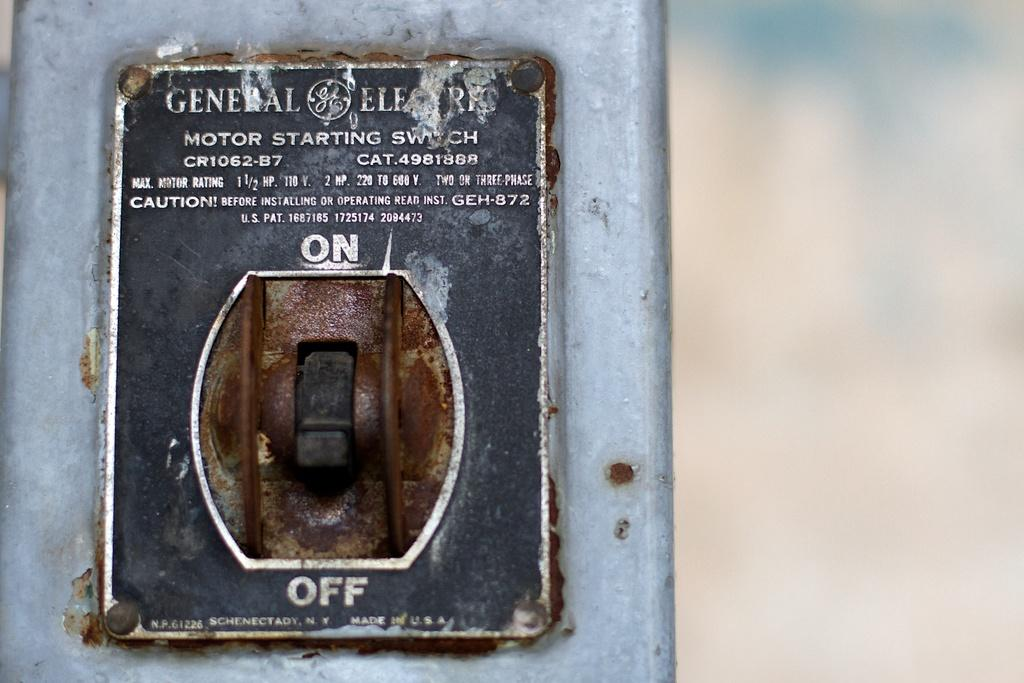What type of object is located on the left side of the image? There is a metal object on the left side of the image. What can be found on the metal object? The metal object has text on it and a switch. What is visible on the right side of the image? There is a blurry view on the right side of the image. What type of stone is being tempered in the image? There is no stone or tempering process visible in the image. 